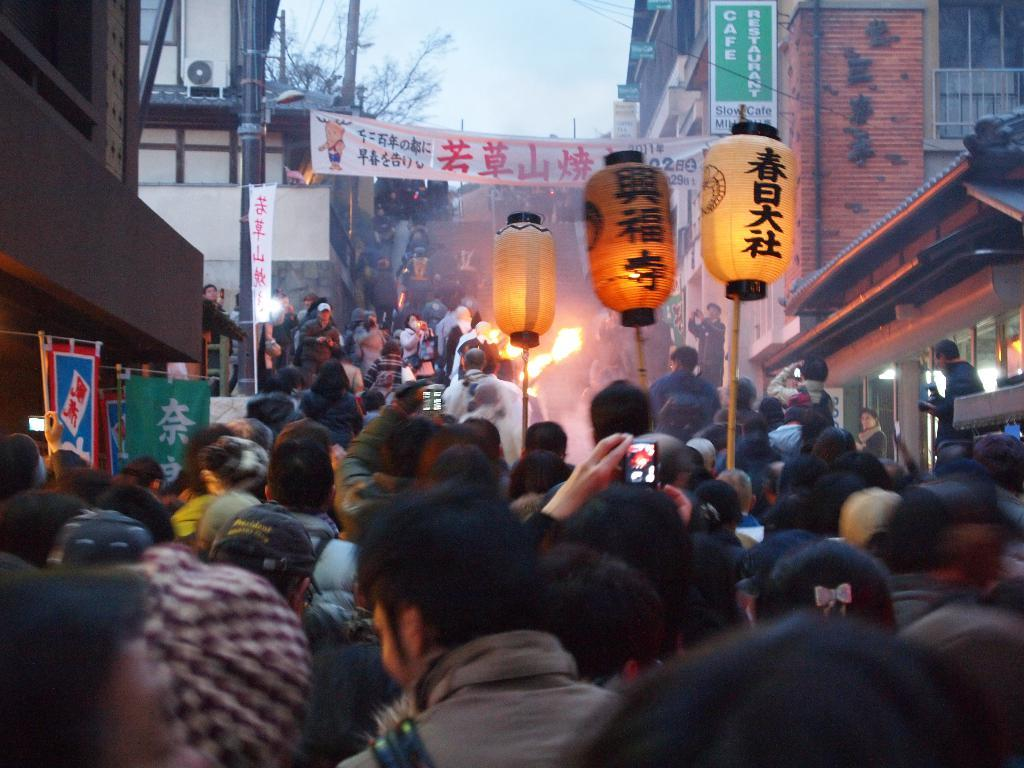How many people are in the image? There is a group of people in the image. What can be seen in the background of the image? There are buildings, trees, banners, and the sky visible in the background of the image. What type of offer is being made by the person on the left's wrist in the image? There is no person on the left's wrist in the image, and no offer is being made. 